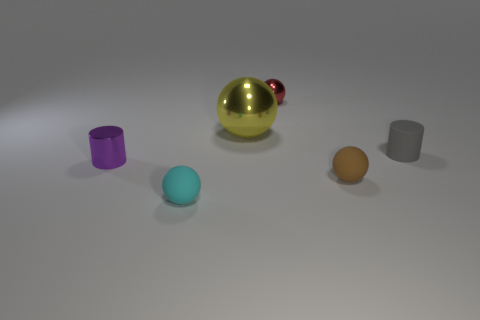Subtract all cyan rubber balls. How many balls are left? 3 Subtract all cyan balls. How many balls are left? 3 Subtract all gray spheres. Subtract all purple cubes. How many spheres are left? 4 Add 1 blue blocks. How many objects exist? 7 Subtract all cylinders. How many objects are left? 4 Add 2 tiny red shiny spheres. How many tiny red shiny spheres are left? 3 Add 1 shiny balls. How many shiny balls exist? 3 Subtract 0 gray cubes. How many objects are left? 6 Subtract all big yellow balls. Subtract all big metal things. How many objects are left? 4 